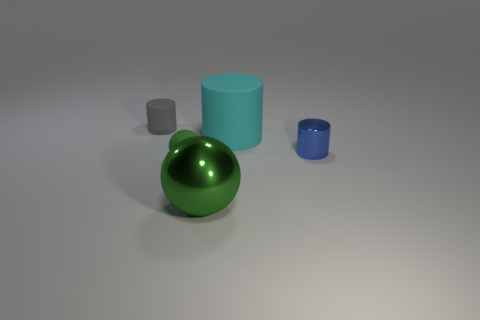Add 5 matte cylinders. How many objects exist? 10 Subtract all spheres. How many objects are left? 3 Subtract all rubber cylinders. How many cylinders are left? 1 Subtract 1 spheres. How many spheres are left? 1 Subtract 0 red cubes. How many objects are left? 5 Subtract all brown spheres. Subtract all red cylinders. How many spheres are left? 2 Subtract all green cylinders. How many gray balls are left? 0 Subtract all small blue objects. Subtract all cyan rubber things. How many objects are left? 3 Add 3 large cyan cylinders. How many large cyan cylinders are left? 4 Add 4 large gray rubber blocks. How many large gray rubber blocks exist? 4 